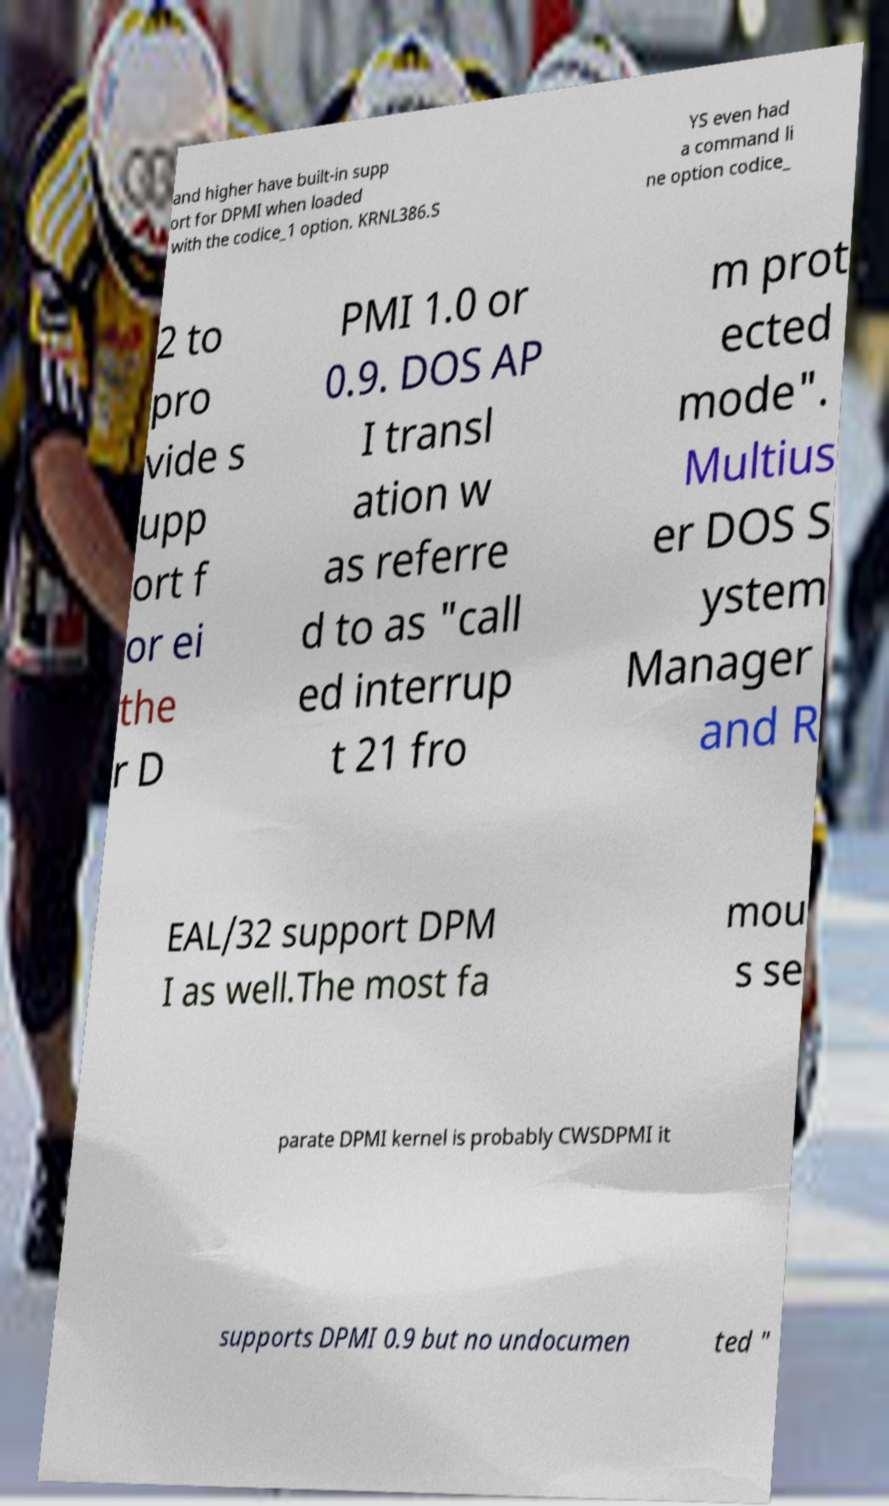Could you assist in decoding the text presented in this image and type it out clearly? and higher have built-in supp ort for DPMI when loaded with the codice_1 option. KRNL386.S YS even had a command li ne option codice_ 2 to pro vide s upp ort f or ei the r D PMI 1.0 or 0.9. DOS AP I transl ation w as referre d to as "call ed interrup t 21 fro m prot ected mode". Multius er DOS S ystem Manager and R EAL/32 support DPM I as well.The most fa mou s se parate DPMI kernel is probably CWSDPMI it supports DPMI 0.9 but no undocumen ted " 